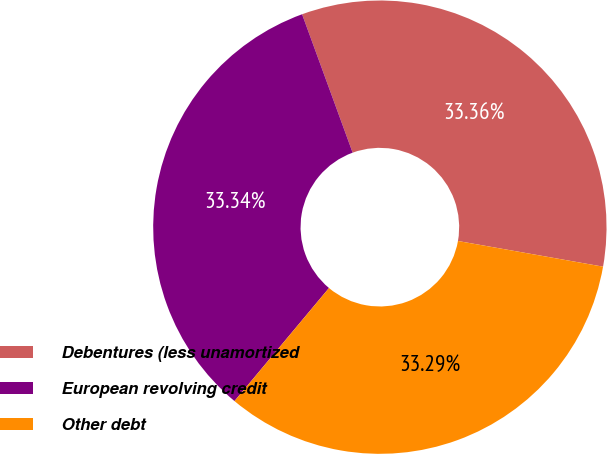<chart> <loc_0><loc_0><loc_500><loc_500><pie_chart><fcel>Debentures (less unamortized<fcel>European revolving credit<fcel>Other debt<nl><fcel>33.36%<fcel>33.34%<fcel>33.29%<nl></chart> 